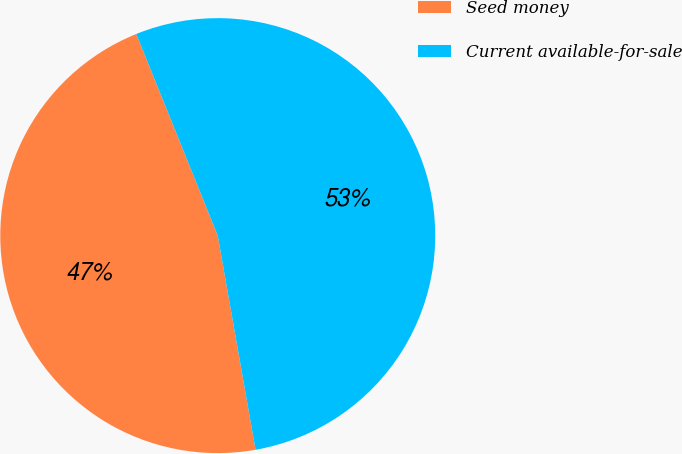Convert chart to OTSL. <chart><loc_0><loc_0><loc_500><loc_500><pie_chart><fcel>Seed money<fcel>Current available-for-sale<nl><fcel>46.67%<fcel>53.33%<nl></chart> 